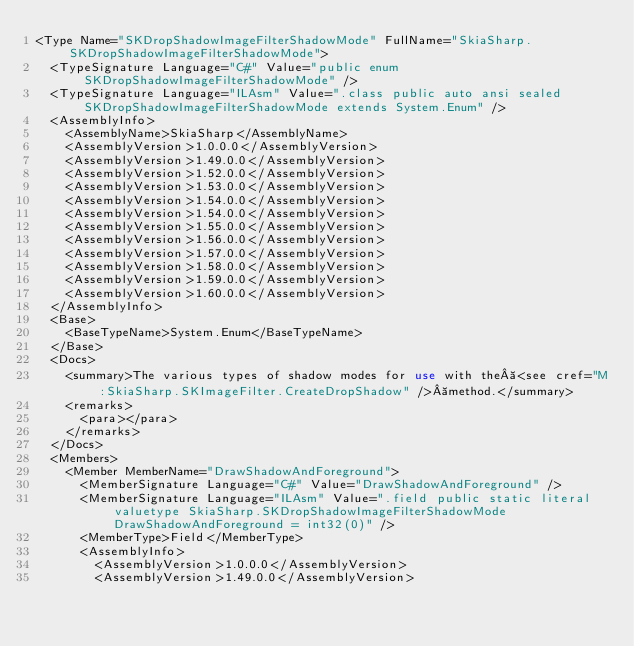<code> <loc_0><loc_0><loc_500><loc_500><_XML_><Type Name="SKDropShadowImageFilterShadowMode" FullName="SkiaSharp.SKDropShadowImageFilterShadowMode">
  <TypeSignature Language="C#" Value="public enum SKDropShadowImageFilterShadowMode" />
  <TypeSignature Language="ILAsm" Value=".class public auto ansi sealed SKDropShadowImageFilterShadowMode extends System.Enum" />
  <AssemblyInfo>
    <AssemblyName>SkiaSharp</AssemblyName>
    <AssemblyVersion>1.0.0.0</AssemblyVersion>
    <AssemblyVersion>1.49.0.0</AssemblyVersion>
    <AssemblyVersion>1.52.0.0</AssemblyVersion>
    <AssemblyVersion>1.53.0.0</AssemblyVersion>
    <AssemblyVersion>1.54.0.0</AssemblyVersion>
    <AssemblyVersion>1.54.0.0</AssemblyVersion>
    <AssemblyVersion>1.55.0.0</AssemblyVersion>
    <AssemblyVersion>1.56.0.0</AssemblyVersion>
    <AssemblyVersion>1.57.0.0</AssemblyVersion>
    <AssemblyVersion>1.58.0.0</AssemblyVersion>
    <AssemblyVersion>1.59.0.0</AssemblyVersion>
    <AssemblyVersion>1.60.0.0</AssemblyVersion>
  </AssemblyInfo>
  <Base>
    <BaseTypeName>System.Enum</BaseTypeName>
  </Base>
  <Docs>
    <summary>The various types of shadow modes for use with the <see cref="M:SkiaSharp.SKImageFilter.CreateDropShadow" /> method.</summary>
    <remarks>
      <para></para>
    </remarks>
  </Docs>
  <Members>
    <Member MemberName="DrawShadowAndForeground">
      <MemberSignature Language="C#" Value="DrawShadowAndForeground" />
      <MemberSignature Language="ILAsm" Value=".field public static literal valuetype SkiaSharp.SKDropShadowImageFilterShadowMode DrawShadowAndForeground = int32(0)" />
      <MemberType>Field</MemberType>
      <AssemblyInfo>
        <AssemblyVersion>1.0.0.0</AssemblyVersion>
        <AssemblyVersion>1.49.0.0</AssemblyVersion></code> 